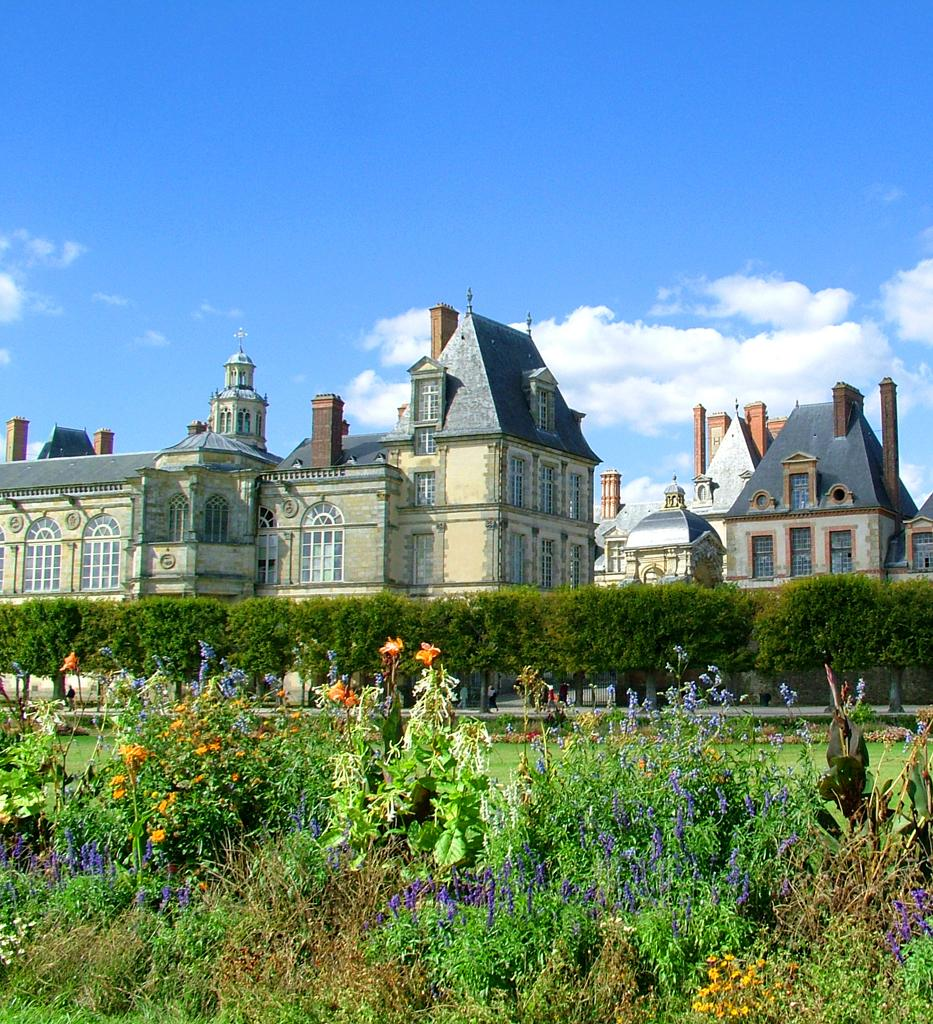What type of living organisms can be seen in the image? Plants and flowers are visible in the image. What is the color of the plants in the image? The plants are green in color. What is the color of the flowers in the image? The flowers are purple and orange in color. What can be seen in the background of the image? Trees, buildings, and the sky are visible in the background of the image. How many eyes can be seen on the truck in the image? There is no truck present in the image, so it is not possible to determine the number of eyes on a truck. 